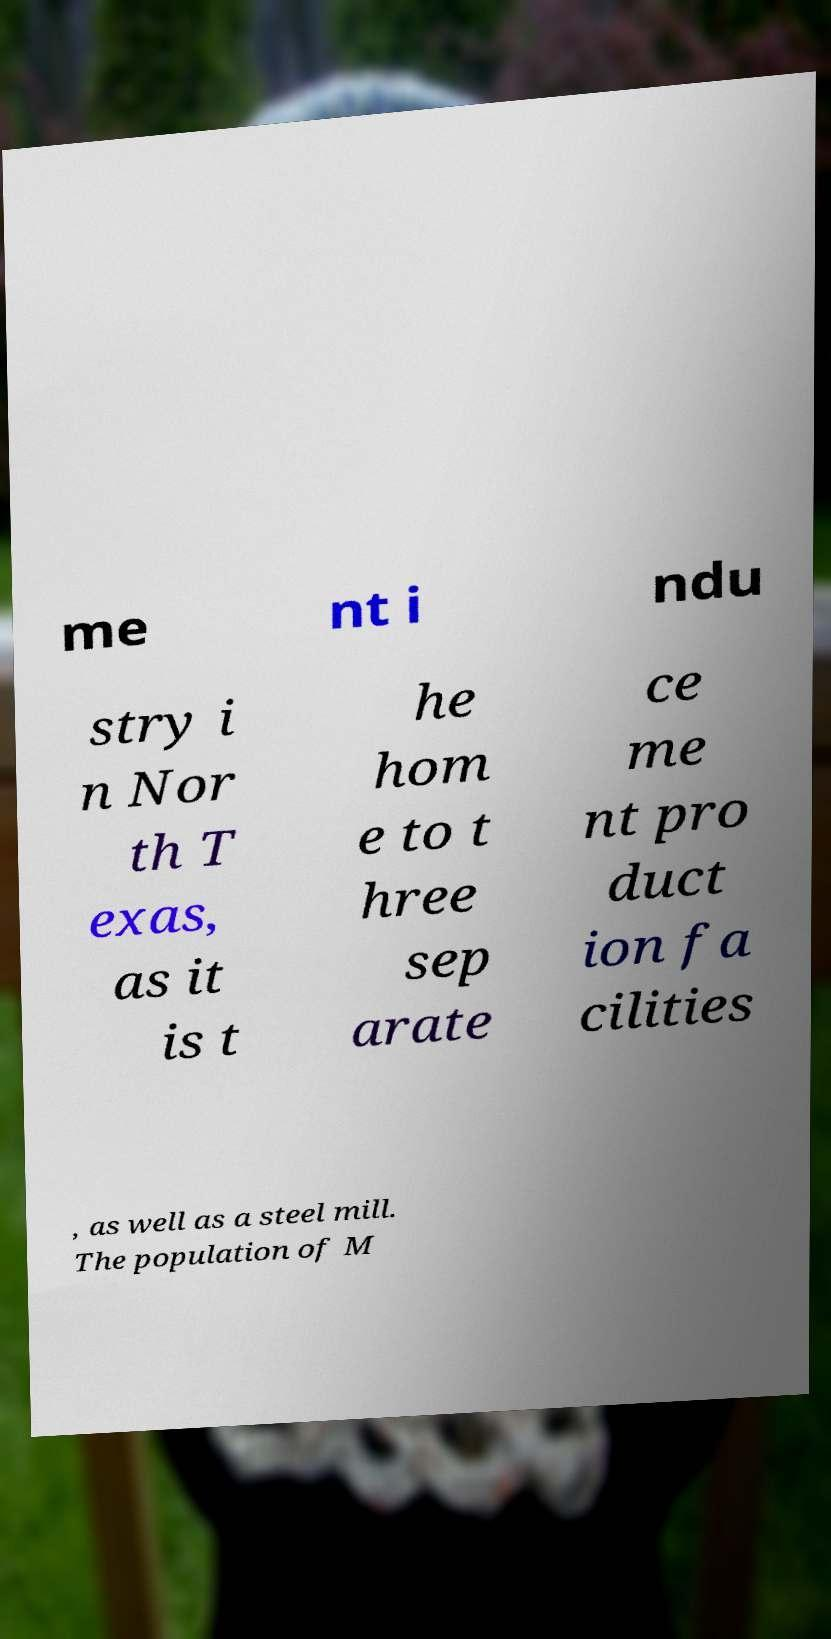For documentation purposes, I need the text within this image transcribed. Could you provide that? me nt i ndu stry i n Nor th T exas, as it is t he hom e to t hree sep arate ce me nt pro duct ion fa cilities , as well as a steel mill. The population of M 